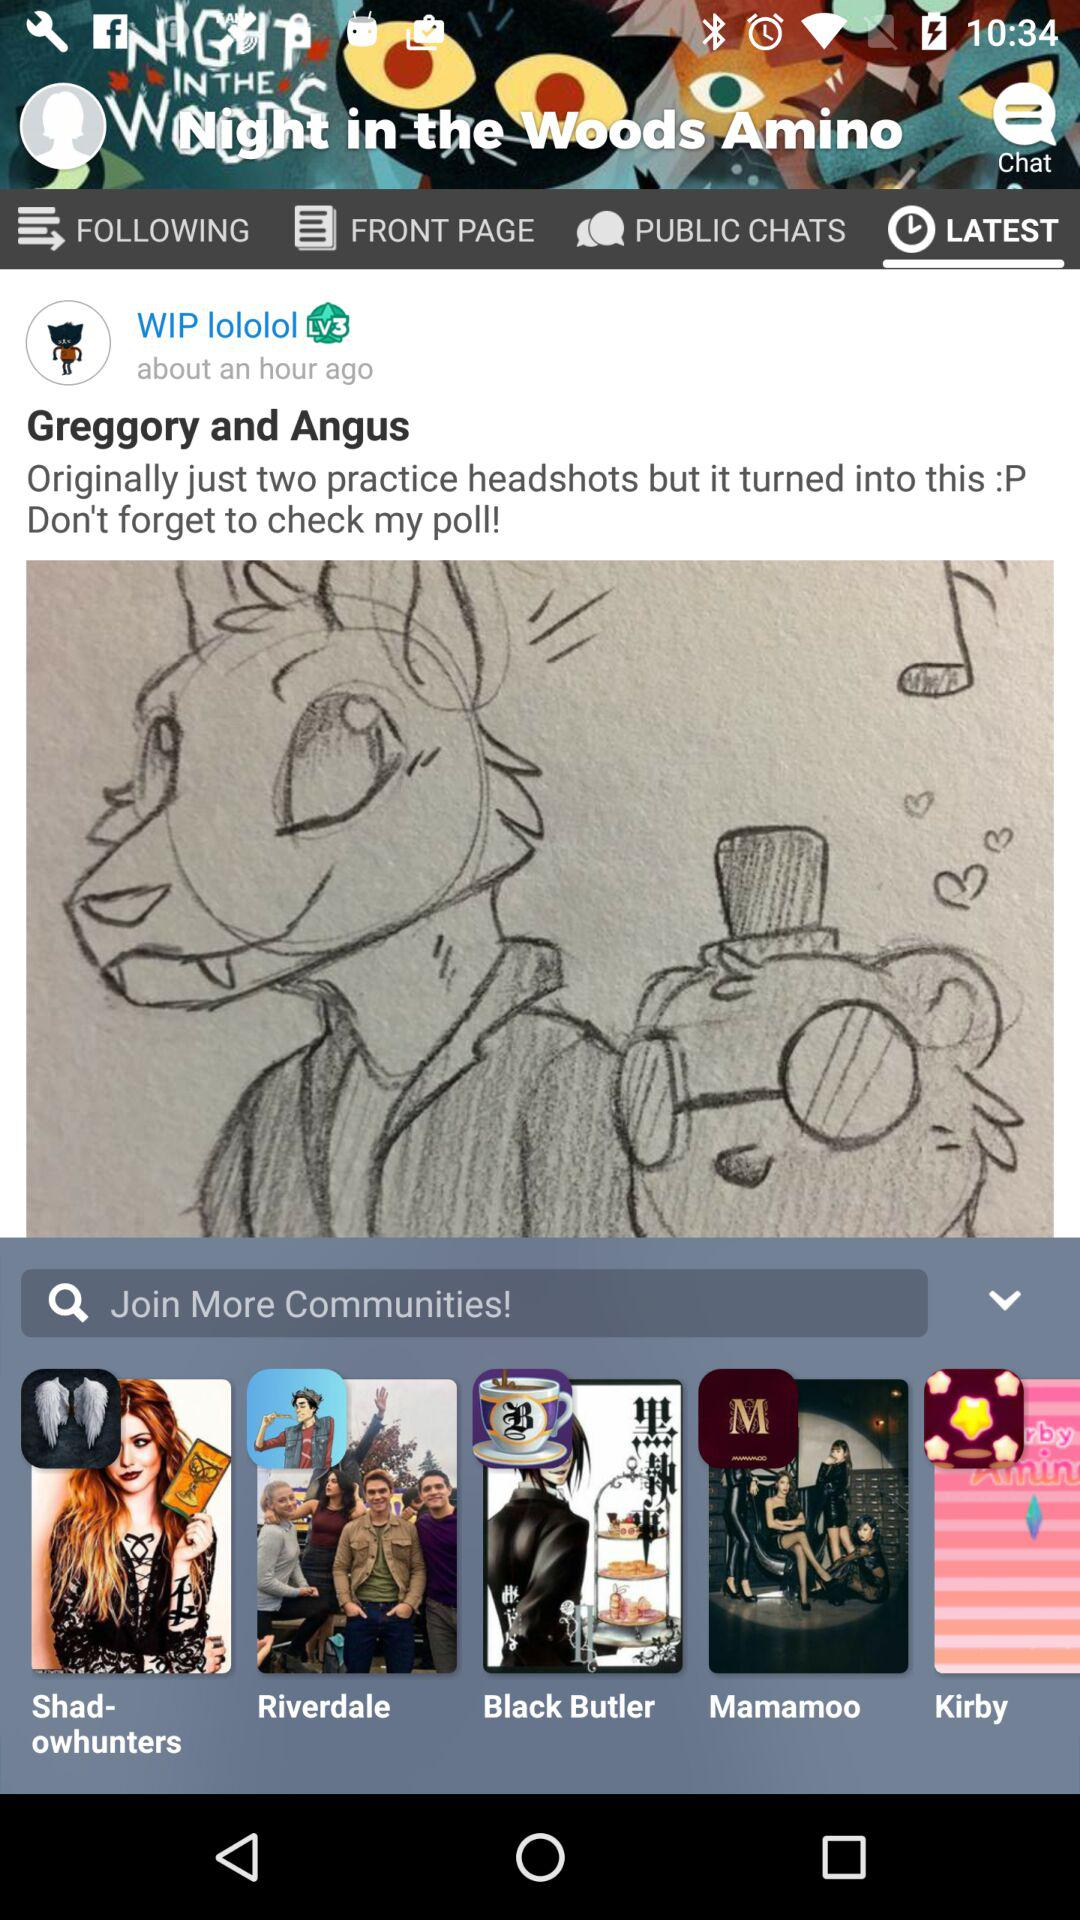Which tab is selected? The selected tab "LATEST". 